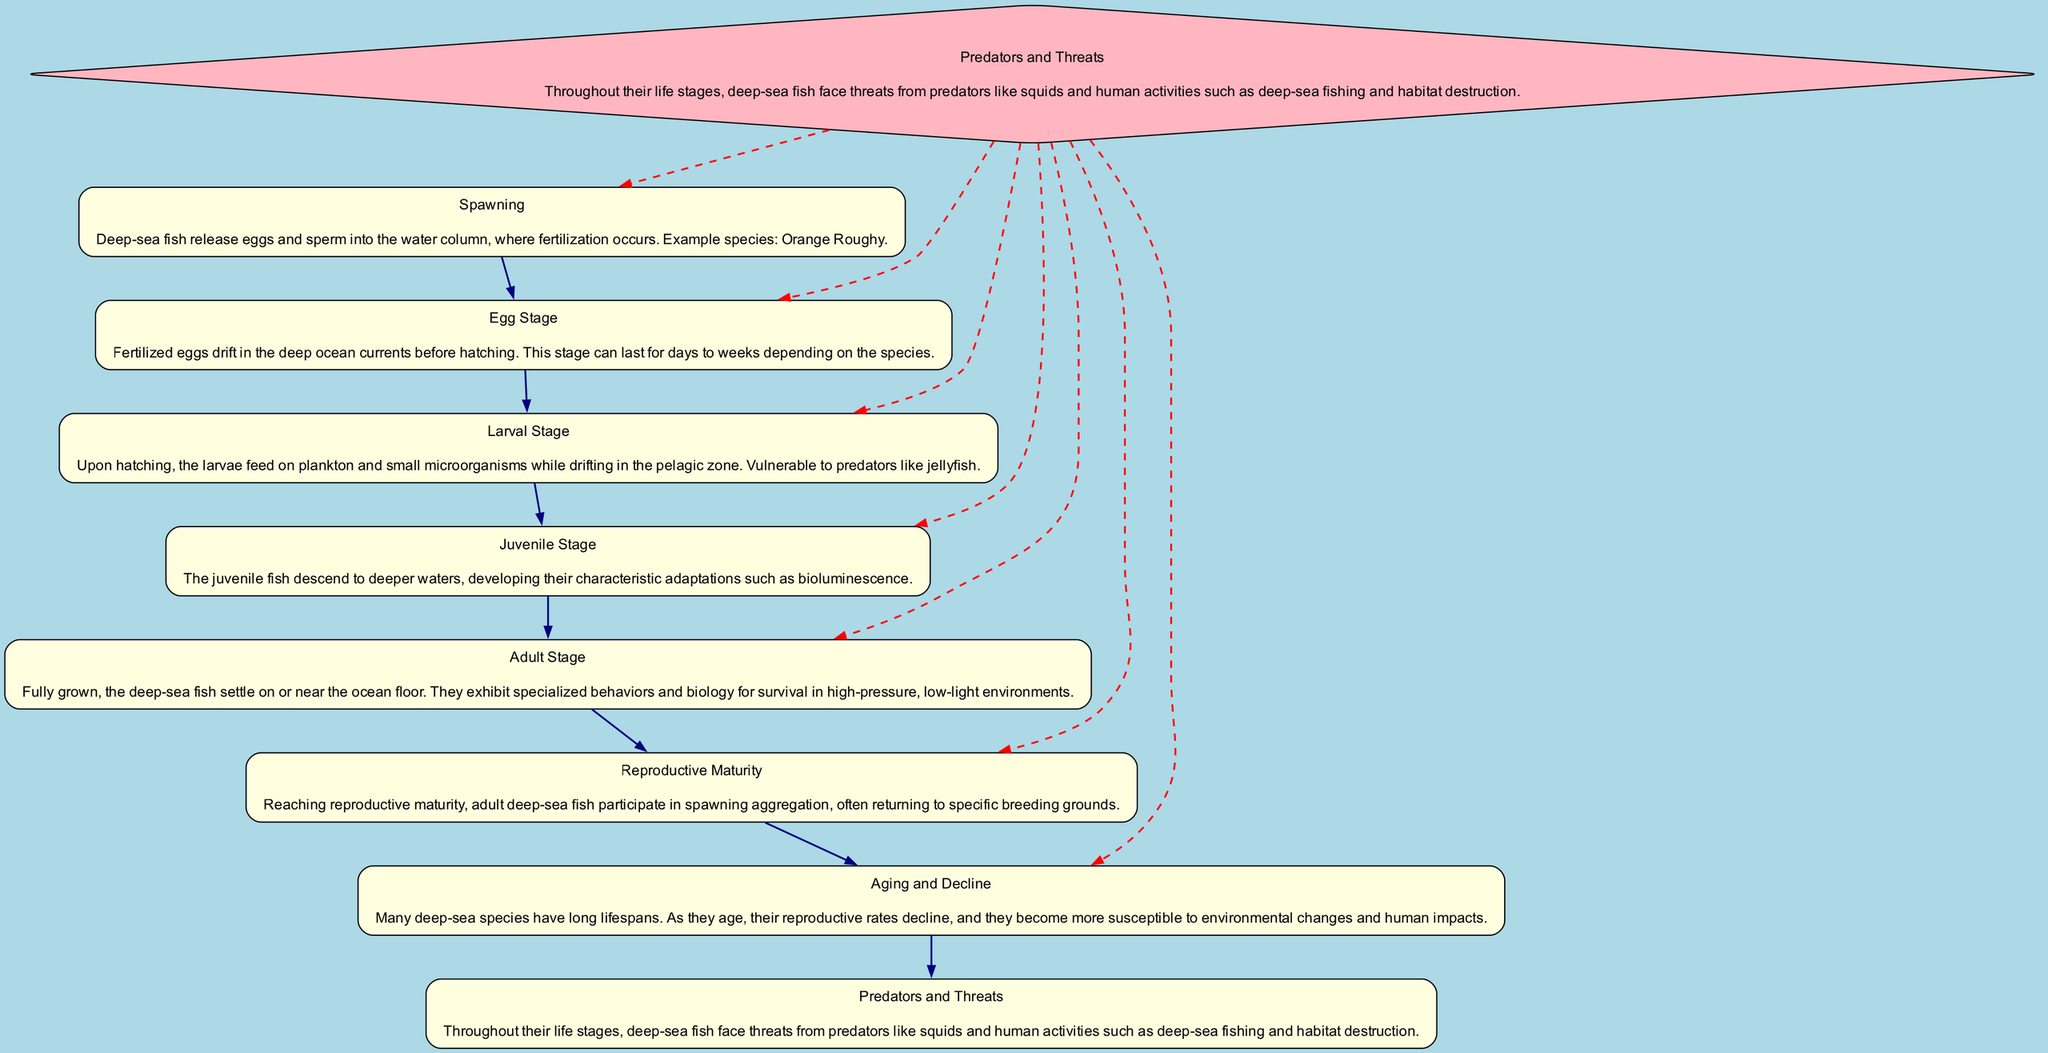What is the first stage in the life cycle of a deep-sea fish? The diagram starts with the "Spawning" stage, which indicates it is the first stage.
Answer: Spawning How many stages are there in the life cycle of the deep-sea fish? The diagram describes seven distinct stages, from Spawning to Aging and Decline.
Answer: Seven Which stage follows the "Egg Stage"? The flow in the diagram shows that after the "Egg Stage," the next stage is the "Larval Stage."
Answer: Larval Stage What is the color of the node representing threats in the diagram? The node labeled "Predators and Threats" is shown in light pink according to the specified style in the diagram.
Answer: Light pink What type of relationship is represented between the "Predators and Threats" node and others? The edges connecting "Predators and Threats" to other nodes are dashed, indicating a different type of relationship compared to the solid edges.
Answer: Dashed What unique feature of the juvenile fish is mentioned in the diagram? The "Juvenile Stage" highlights the development of bioluminescence as a characteristic adaptation.
Answer: Bioluminescence At what stage do deep-sea fish reach reproductive maturity? The stage labeled "Reproductive Maturity" in the diagram clearly indicates when adult deep-sea fish reach this level.
Answer: Reproductive Maturity During which stage are deep-sea fish vulnerable to predators? The vulnerability to predators is described specifically during the "Larval Stage" of the life cycle.
Answer: Larval Stage What happens to deep-sea fish as they age? The "Aging and Decline" stage illustrates that many species experience a decline in reproductive rates and increased susceptibility to changes.
Answer: Decline in reproductive rates 